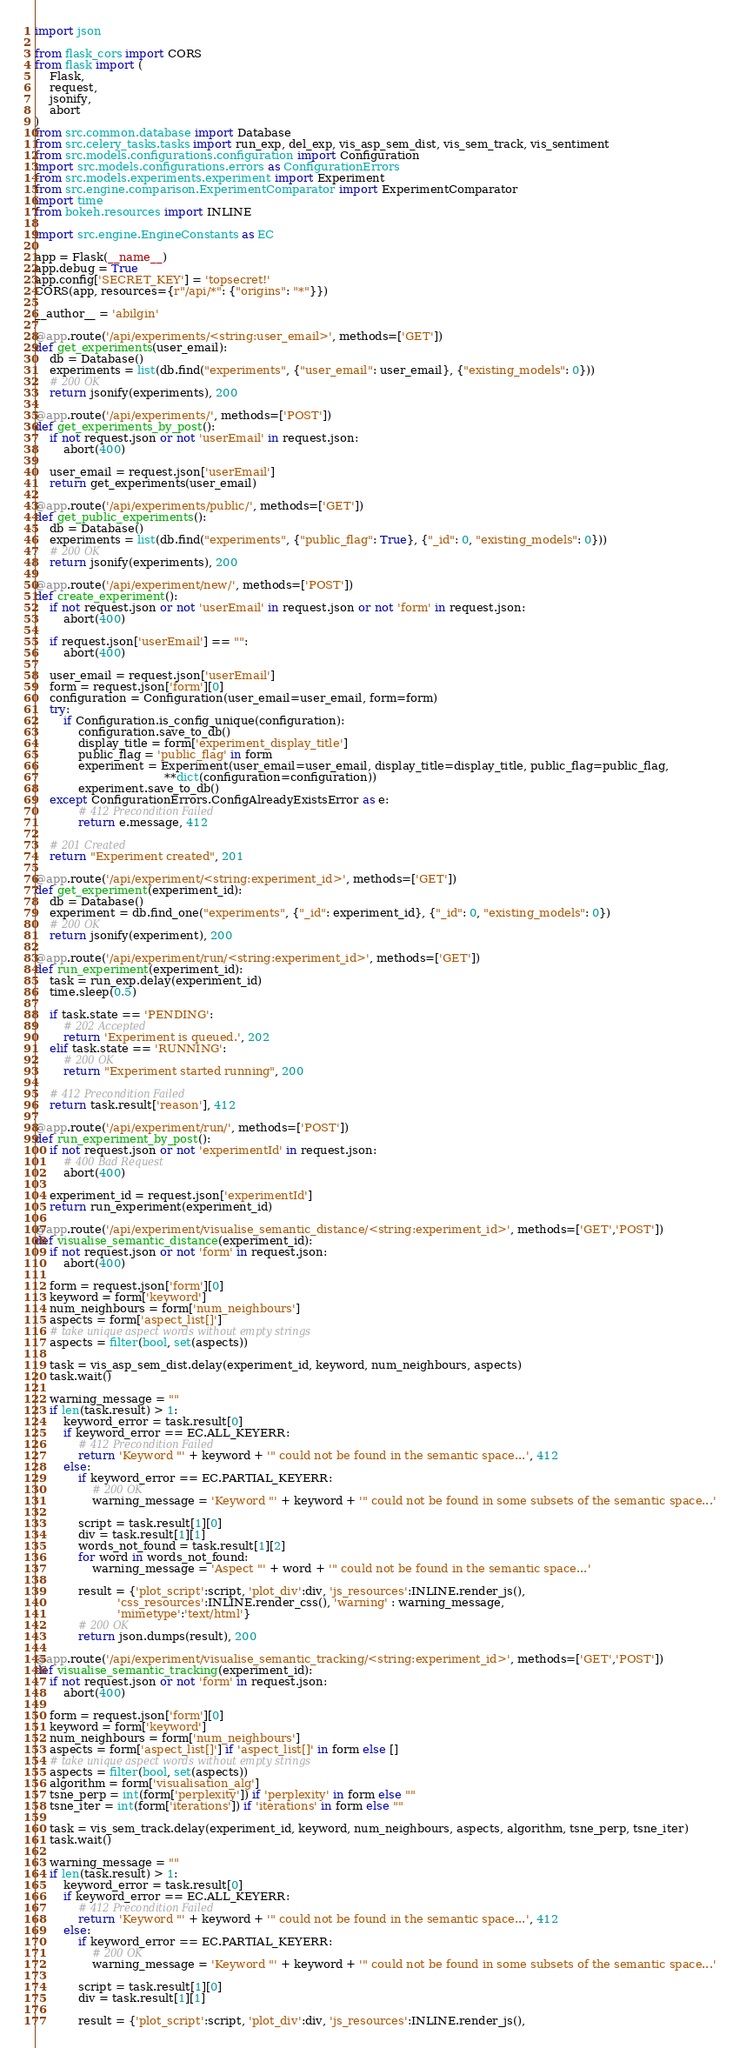Convert code to text. <code><loc_0><loc_0><loc_500><loc_500><_Python_>import json

from flask_cors import CORS
from flask import (
    Flask,
    request,
    jsonify,
    abort
)
from src.common.database import Database
from src.celery_tasks.tasks import run_exp, del_exp, vis_asp_sem_dist, vis_sem_track, vis_sentiment
from src.models.configurations.configuration import Configuration
import src.models.configurations.errors as ConfigurationErrors
from src.models.experiments.experiment import Experiment
from src.engine.comparison.ExperimentComparator import ExperimentComparator
import time
from bokeh.resources import INLINE

import src.engine.EngineConstants as EC

app = Flask(__name__)
app.debug = True
app.config['SECRET_KEY'] = 'topsecret!'
CORS(app, resources={r"/api/*": {"origins": "*"}})

__author__ = 'abilgin'

@app.route('/api/experiments/<string:user_email>', methods=['GET'])
def get_experiments(user_email):
    db = Database()
    experiments = list(db.find("experiments", {"user_email": user_email}, {"existing_models": 0}))
    # 200 OK
    return jsonify(experiments), 200

@app.route('/api/experiments/', methods=['POST'])
def get_experiments_by_post():
    if not request.json or not 'userEmail' in request.json:
        abort(400)

    user_email = request.json['userEmail']
    return get_experiments(user_email)

@app.route('/api/experiments/public/', methods=['GET'])
def get_public_experiments():
    db = Database()
    experiments = list(db.find("experiments", {"public_flag": True}, {"_id": 0, "existing_models": 0}))
    # 200 OK
    return jsonify(experiments), 200

@app.route('/api/experiment/new/', methods=['POST'])
def create_experiment():
    if not request.json or not 'userEmail' in request.json or not 'form' in request.json:
        abort(400)

    if request.json['userEmail'] == "":
        abort(400)

    user_email = request.json['userEmail']
    form = request.json['form'][0]
    configuration = Configuration(user_email=user_email, form=form)
    try:
        if Configuration.is_config_unique(configuration):
            configuration.save_to_db()
            display_title = form['experiment_display_title']
            public_flag = 'public_flag' in form
            experiment = Experiment(user_email=user_email, display_title=display_title, public_flag=public_flag,
                                    **dict(configuration=configuration))
            experiment.save_to_db()
    except ConfigurationErrors.ConfigAlreadyExistsError as e:
            # 412 Precondition Failed
            return e.message, 412

    # 201 Created
    return "Experiment created", 201

@app.route('/api/experiment/<string:experiment_id>', methods=['GET'])
def get_experiment(experiment_id):
    db = Database()
    experiment = db.find_one("experiments", {"_id": experiment_id}, {"_id": 0, "existing_models": 0})
    # 200 OK
    return jsonify(experiment), 200

@app.route('/api/experiment/run/<string:experiment_id>', methods=['GET'])
def run_experiment(experiment_id):
    task = run_exp.delay(experiment_id)
    time.sleep(0.5)

    if task.state == 'PENDING':
        # 202 Accepted
        return 'Experiment is queued.', 202
    elif task.state == 'RUNNING':
        # 200 OK
        return "Experiment started running", 200

    # 412 Precondition Failed
    return task.result['reason'], 412

@app.route('/api/experiment/run/', methods=['POST'])
def run_experiment_by_post():
    if not request.json or not 'experimentId' in request.json:
        # 400 Bad Request
        abort(400)

    experiment_id = request.json['experimentId']
    return run_experiment(experiment_id)

@app.route('/api/experiment/visualise_semantic_distance/<string:experiment_id>', methods=['GET','POST'])
def visualise_semantic_distance(experiment_id):
    if not request.json or not 'form' in request.json:
        abort(400)

    form = request.json['form'][0]
    keyword = form['keyword']
    num_neighbours = form['num_neighbours']
    aspects = form['aspect_list[]']
    # take unique aspect words without empty strings
    aspects = filter(bool, set(aspects))

    task = vis_asp_sem_dist.delay(experiment_id, keyword, num_neighbours, aspects)
    task.wait()

    warning_message = ""
    if len(task.result) > 1:
        keyword_error = task.result[0]
        if keyword_error == EC.ALL_KEYERR:
            # 412 Precondition Failed
            return 'Keyword "' + keyword + '" could not be found in the semantic space...', 412
        else:
            if keyword_error == EC.PARTIAL_KEYERR:
                # 200 OK
                warning_message = 'Keyword "' + keyword + '" could not be found in some subsets of the semantic space...'

            script = task.result[1][0]
            div = task.result[1][1]
            words_not_found = task.result[1][2]
            for word in words_not_found:
                warning_message = 'Aspect "' + word + '" could not be found in the semantic space...'

            result = {'plot_script':script, 'plot_div':div, 'js_resources':INLINE.render_js(),
                       'css_resources':INLINE.render_css(), 'warning' : warning_message,
                       'mimetype':'text/html'}
            # 200 OK
            return json.dumps(result), 200

@app.route('/api/experiment/visualise_semantic_tracking/<string:experiment_id>', methods=['GET','POST'])
def visualise_semantic_tracking(experiment_id):
    if not request.json or not 'form' in request.json:
        abort(400)

    form = request.json['form'][0]
    keyword = form['keyword']
    num_neighbours = form['num_neighbours']
    aspects = form['aspect_list[]'] if 'aspect_list[]' in form else []
    # take unique aspect words without empty strings
    aspects = filter(bool, set(aspects))
    algorithm = form['visualisation_alg']
    tsne_perp = int(form['perplexity']) if 'perplexity' in form else ""
    tsne_iter = int(form['iterations']) if 'iterations' in form else ""

    task = vis_sem_track.delay(experiment_id, keyword, num_neighbours, aspects, algorithm, tsne_perp, tsne_iter)
    task.wait()

    warning_message = ""
    if len(task.result) > 1:
        keyword_error = task.result[0]
        if keyword_error == EC.ALL_KEYERR:
            # 412 Precondition Failed
            return 'Keyword "' + keyword + '" could not be found in the semantic space...', 412
        else:
            if keyword_error == EC.PARTIAL_KEYERR:
                # 200 OK
                warning_message = 'Keyword "' + keyword + '" could not be found in some subsets of the semantic space...'

            script = task.result[1][0]
            div = task.result[1][1]

            result = {'plot_script':script, 'plot_div':div, 'js_resources':INLINE.render_js(),</code> 